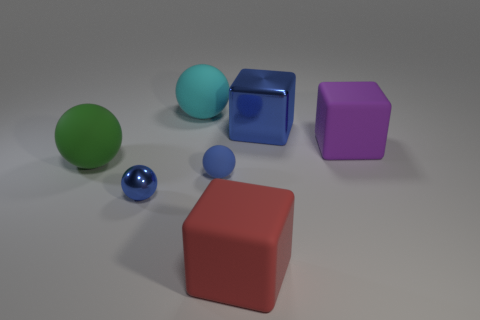Add 2 red cubes. How many objects exist? 9 Subtract all spheres. How many objects are left? 3 Add 1 green rubber cylinders. How many green rubber cylinders exist? 1 Subtract 0 red cylinders. How many objects are left? 7 Subtract all small cyan rubber things. Subtract all large purple rubber blocks. How many objects are left? 6 Add 4 green rubber spheres. How many green rubber spheres are left? 5 